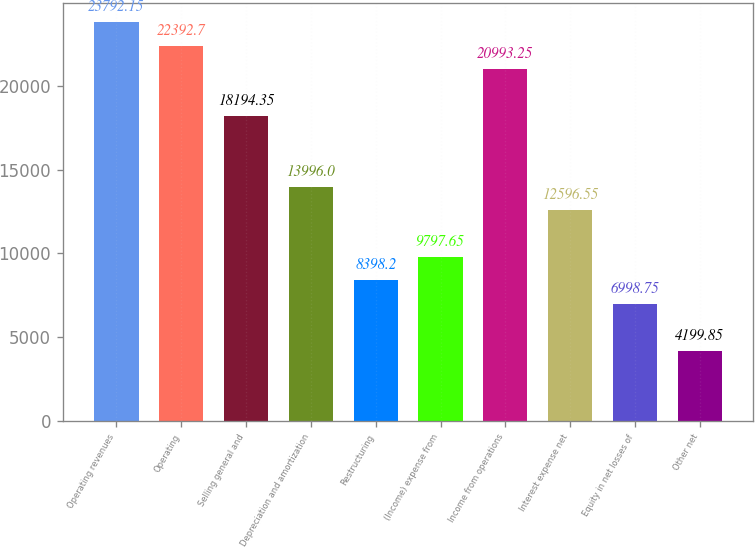Convert chart. <chart><loc_0><loc_0><loc_500><loc_500><bar_chart><fcel>Operating revenues<fcel>Operating<fcel>Selling general and<fcel>Depreciation and amortization<fcel>Restructuring<fcel>(Income) expense from<fcel>Income from operations<fcel>Interest expense net<fcel>Equity in net losses of<fcel>Other net<nl><fcel>23792.2<fcel>22392.7<fcel>18194.3<fcel>13996<fcel>8398.2<fcel>9797.65<fcel>20993.2<fcel>12596.5<fcel>6998.75<fcel>4199.85<nl></chart> 